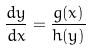<formula> <loc_0><loc_0><loc_500><loc_500>\frac { d y } { d x } = \frac { g ( x ) } { h ( y ) }</formula> 